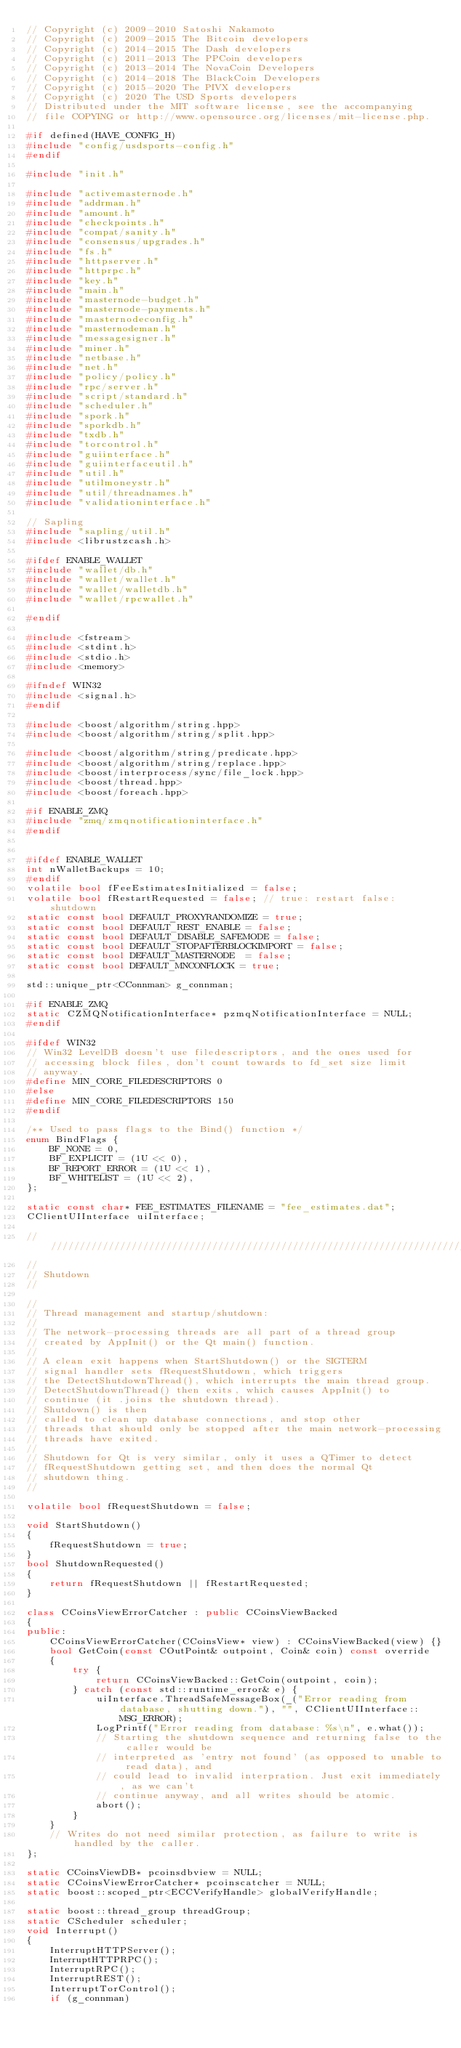<code> <loc_0><loc_0><loc_500><loc_500><_C++_>// Copyright (c) 2009-2010 Satoshi Nakamoto
// Copyright (c) 2009-2015 The Bitcoin developers
// Copyright (c) 2014-2015 The Dash developers
// Copyright (c) 2011-2013 The PPCoin developers
// Copyright (c) 2013-2014 The NovaCoin Developers
// Copyright (c) 2014-2018 The BlackCoin Developers
// Copyright (c) 2015-2020 The PIVX developers
// Copyright (c) 2020 The USD Sports developers
// Distributed under the MIT software license, see the accompanying
// file COPYING or http://www.opensource.org/licenses/mit-license.php.

#if defined(HAVE_CONFIG_H)
#include "config/usdsports-config.h"
#endif

#include "init.h"

#include "activemasternode.h"
#include "addrman.h"
#include "amount.h"
#include "checkpoints.h"
#include "compat/sanity.h"
#include "consensus/upgrades.h"
#include "fs.h"
#include "httpserver.h"
#include "httprpc.h"
#include "key.h"
#include "main.h"
#include "masternode-budget.h"
#include "masternode-payments.h"
#include "masternodeconfig.h"
#include "masternodeman.h"
#include "messagesigner.h"
#include "miner.h"
#include "netbase.h"
#include "net.h"
#include "policy/policy.h"
#include "rpc/server.h"
#include "script/standard.h"
#include "scheduler.h"
#include "spork.h"
#include "sporkdb.h"
#include "txdb.h"
#include "torcontrol.h"
#include "guiinterface.h"
#include "guiinterfaceutil.h"
#include "util.h"
#include "utilmoneystr.h"
#include "util/threadnames.h"
#include "validationinterface.h"

// Sapling
#include "sapling/util.h"
#include <librustzcash.h>

#ifdef ENABLE_WALLET
#include "wallet/db.h"
#include "wallet/wallet.h"
#include "wallet/walletdb.h"
#include "wallet/rpcwallet.h"

#endif

#include <fstream>
#include <stdint.h>
#include <stdio.h>
#include <memory>

#ifndef WIN32
#include <signal.h>
#endif

#include <boost/algorithm/string.hpp>
#include <boost/algorithm/string/split.hpp>

#include <boost/algorithm/string/predicate.hpp>
#include <boost/algorithm/string/replace.hpp>
#include <boost/interprocess/sync/file_lock.hpp>
#include <boost/thread.hpp>
#include <boost/foreach.hpp>

#if ENABLE_ZMQ
#include "zmq/zmqnotificationinterface.h"
#endif


#ifdef ENABLE_WALLET
int nWalletBackups = 10;
#endif
volatile bool fFeeEstimatesInitialized = false;
volatile bool fRestartRequested = false; // true: restart false: shutdown
static const bool DEFAULT_PROXYRANDOMIZE = true;
static const bool DEFAULT_REST_ENABLE = false;
static const bool DEFAULT_DISABLE_SAFEMODE = false;
static const bool DEFAULT_STOPAFTERBLOCKIMPORT = false;
static const bool DEFAULT_MASTERNODE  = false;
static const bool DEFAULT_MNCONFLOCK = true;

std::unique_ptr<CConnman> g_connman;

#if ENABLE_ZMQ
static CZMQNotificationInterface* pzmqNotificationInterface = NULL;
#endif

#ifdef WIN32
// Win32 LevelDB doesn't use filedescriptors, and the ones used for
// accessing block files, don't count towards to fd_set size limit
// anyway.
#define MIN_CORE_FILEDESCRIPTORS 0
#else
#define MIN_CORE_FILEDESCRIPTORS 150
#endif

/** Used to pass flags to the Bind() function */
enum BindFlags {
    BF_NONE = 0,
    BF_EXPLICIT = (1U << 0),
    BF_REPORT_ERROR = (1U << 1),
    BF_WHITELIST = (1U << 2),
};

static const char* FEE_ESTIMATES_FILENAME = "fee_estimates.dat";
CClientUIInterface uiInterface;

//////////////////////////////////////////////////////////////////////////////
//
// Shutdown
//

//
// Thread management and startup/shutdown:
//
// The network-processing threads are all part of a thread group
// created by AppInit() or the Qt main() function.
//
// A clean exit happens when StartShutdown() or the SIGTERM
// signal handler sets fRequestShutdown, which triggers
// the DetectShutdownThread(), which interrupts the main thread group.
// DetectShutdownThread() then exits, which causes AppInit() to
// continue (it .joins the shutdown thread).
// Shutdown() is then
// called to clean up database connections, and stop other
// threads that should only be stopped after the main network-processing
// threads have exited.
//
// Shutdown for Qt is very similar, only it uses a QTimer to detect
// fRequestShutdown getting set, and then does the normal Qt
// shutdown thing.
//

volatile bool fRequestShutdown = false;

void StartShutdown()
{
    fRequestShutdown = true;
}
bool ShutdownRequested()
{
    return fRequestShutdown || fRestartRequested;
}

class CCoinsViewErrorCatcher : public CCoinsViewBacked
{
public:
    CCoinsViewErrorCatcher(CCoinsView* view) : CCoinsViewBacked(view) {}
    bool GetCoin(const COutPoint& outpoint, Coin& coin) const override
    {
        try {
            return CCoinsViewBacked::GetCoin(outpoint, coin);
        } catch (const std::runtime_error& e) {
            uiInterface.ThreadSafeMessageBox(_("Error reading from database, shutting down."), "", CClientUIInterface::MSG_ERROR);
            LogPrintf("Error reading from database: %s\n", e.what());
            // Starting the shutdown sequence and returning false to the caller would be
            // interpreted as 'entry not found' (as opposed to unable to read data), and
            // could lead to invalid interpration. Just exit immediately, as we can't
            // continue anyway, and all writes should be atomic.
            abort();
        }
    }
    // Writes do not need similar protection, as failure to write is handled by the caller.
};

static CCoinsViewDB* pcoinsdbview = NULL;
static CCoinsViewErrorCatcher* pcoinscatcher = NULL;
static boost::scoped_ptr<ECCVerifyHandle> globalVerifyHandle;

static boost::thread_group threadGroup;
static CScheduler scheduler;
void Interrupt()
{
    InterruptHTTPServer();
    InterruptHTTPRPC();
    InterruptRPC();
    InterruptREST();
    InterruptTorControl();
    if (g_connman)</code> 